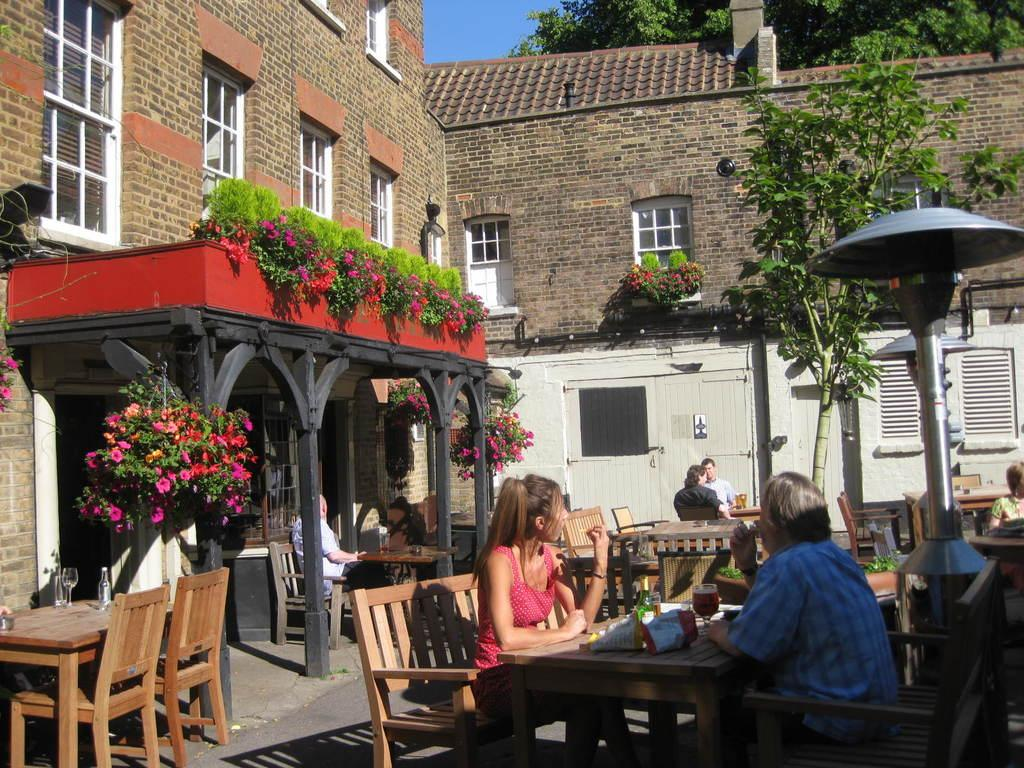Where is the image taken? The image is taken outside a building. What type of furniture is visible in the image? There are dining tables and chairs in the image. What are the people in the image doing? People are sitting on the dining tables and chairs. Can you describe any decorative elements in the image? There is an arch with plant flowers in the image. What type of location might this image depict? The location appears to be outside a hotel area. What type of cart is being used by the lawyer in the image? There is no lawyer or cart present in the image. How does the railway system connect to the hotel area in the image? There is no railway system visible in the image, so it cannot be determined how it connects to the hotel area. 